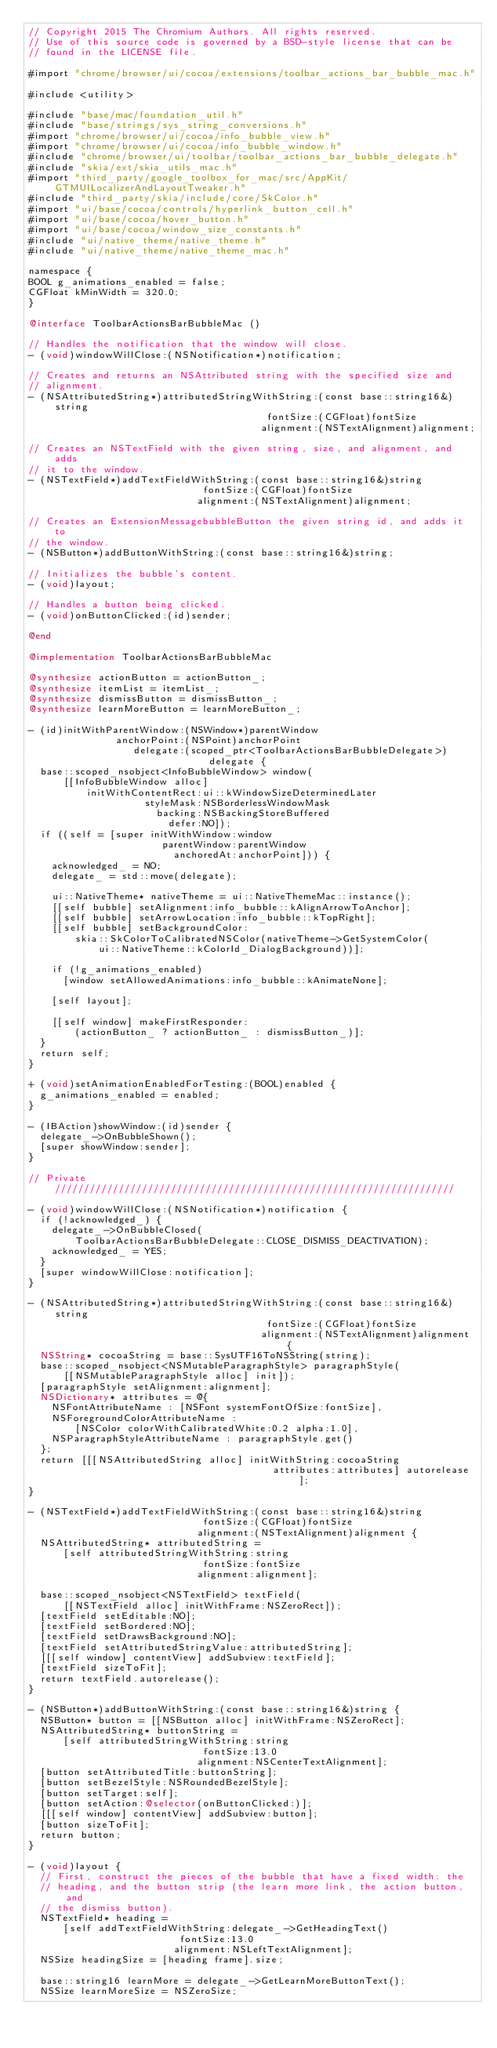<code> <loc_0><loc_0><loc_500><loc_500><_ObjectiveC_>// Copyright 2015 The Chromium Authors. All rights reserved.
// Use of this source code is governed by a BSD-style license that can be
// found in the LICENSE file.

#import "chrome/browser/ui/cocoa/extensions/toolbar_actions_bar_bubble_mac.h"

#include <utility>

#include "base/mac/foundation_util.h"
#include "base/strings/sys_string_conversions.h"
#import "chrome/browser/ui/cocoa/info_bubble_view.h"
#import "chrome/browser/ui/cocoa/info_bubble_window.h"
#include "chrome/browser/ui/toolbar/toolbar_actions_bar_bubble_delegate.h"
#include "skia/ext/skia_utils_mac.h"
#import "third_party/google_toolbox_for_mac/src/AppKit/GTMUILocalizerAndLayoutTweaker.h"
#include "third_party/skia/include/core/SkColor.h"
#import "ui/base/cocoa/controls/hyperlink_button_cell.h"
#import "ui/base/cocoa/hover_button.h"
#import "ui/base/cocoa/window_size_constants.h"
#include "ui/native_theme/native_theme.h"
#include "ui/native_theme/native_theme_mac.h"

namespace {
BOOL g_animations_enabled = false;
CGFloat kMinWidth = 320.0;
}

@interface ToolbarActionsBarBubbleMac ()

// Handles the notification that the window will close.
- (void)windowWillClose:(NSNotification*)notification;

// Creates and returns an NSAttributed string with the specified size and
// alignment.
- (NSAttributedString*)attributedStringWithString:(const base::string16&)string
                                         fontSize:(CGFloat)fontSize
                                        alignment:(NSTextAlignment)alignment;

// Creates an NSTextField with the given string, size, and alignment, and adds
// it to the window.
- (NSTextField*)addTextFieldWithString:(const base::string16&)string
                              fontSize:(CGFloat)fontSize
                             alignment:(NSTextAlignment)alignment;

// Creates an ExtensionMessagebubbleButton the given string id, and adds it to
// the window.
- (NSButton*)addButtonWithString:(const base::string16&)string;

// Initializes the bubble's content.
- (void)layout;

// Handles a button being clicked.
- (void)onButtonClicked:(id)sender;

@end

@implementation ToolbarActionsBarBubbleMac

@synthesize actionButton = actionButton_;
@synthesize itemList = itemList_;
@synthesize dismissButton = dismissButton_;
@synthesize learnMoreButton = learnMoreButton_;

- (id)initWithParentWindow:(NSWindow*)parentWindow
               anchorPoint:(NSPoint)anchorPoint
                  delegate:(scoped_ptr<ToolbarActionsBarBubbleDelegate>)
                               delegate {
  base::scoped_nsobject<InfoBubbleWindow> window(
      [[InfoBubbleWindow alloc]
          initWithContentRect:ui::kWindowSizeDeterminedLater
                    styleMask:NSBorderlessWindowMask
                      backing:NSBackingStoreBuffered
                        defer:NO]);
  if ((self = [super initWithWindow:window
                       parentWindow:parentWindow
                         anchoredAt:anchorPoint])) {
    acknowledged_ = NO;
    delegate_ = std::move(delegate);

    ui::NativeTheme* nativeTheme = ui::NativeThemeMac::instance();
    [[self bubble] setAlignment:info_bubble::kAlignArrowToAnchor];
    [[self bubble] setArrowLocation:info_bubble::kTopRight];
    [[self bubble] setBackgroundColor:
        skia::SkColorToCalibratedNSColor(nativeTheme->GetSystemColor(
            ui::NativeTheme::kColorId_DialogBackground))];

    if (!g_animations_enabled)
      [window setAllowedAnimations:info_bubble::kAnimateNone];

    [self layout];

    [[self window] makeFirstResponder:
        (actionButton_ ? actionButton_ : dismissButton_)];
  }
  return self;
}

+ (void)setAnimationEnabledForTesting:(BOOL)enabled {
  g_animations_enabled = enabled;
}

- (IBAction)showWindow:(id)sender {
  delegate_->OnBubbleShown();
  [super showWindow:sender];
}

// Private /////////////////////////////////////////////////////////////////////

- (void)windowWillClose:(NSNotification*)notification {
  if (!acknowledged_) {
    delegate_->OnBubbleClosed(
        ToolbarActionsBarBubbleDelegate::CLOSE_DISMISS_DEACTIVATION);
    acknowledged_ = YES;
  }
  [super windowWillClose:notification];
}

- (NSAttributedString*)attributedStringWithString:(const base::string16&)string
                                         fontSize:(CGFloat)fontSize
                                        alignment:(NSTextAlignment)alignment {
  NSString* cocoaString = base::SysUTF16ToNSString(string);
  base::scoped_nsobject<NSMutableParagraphStyle> paragraphStyle(
      [[NSMutableParagraphStyle alloc] init]);
  [paragraphStyle setAlignment:alignment];
  NSDictionary* attributes = @{
    NSFontAttributeName : [NSFont systemFontOfSize:fontSize],
    NSForegroundColorAttributeName :
        [NSColor colorWithCalibratedWhite:0.2 alpha:1.0],
    NSParagraphStyleAttributeName : paragraphStyle.get()
  };
  return [[[NSAttributedString alloc] initWithString:cocoaString
                                          attributes:attributes] autorelease];
}

- (NSTextField*)addTextFieldWithString:(const base::string16&)string
                              fontSize:(CGFloat)fontSize
                             alignment:(NSTextAlignment)alignment {
  NSAttributedString* attributedString =
      [self attributedStringWithString:string
                              fontSize:fontSize
                             alignment:alignment];

  base::scoped_nsobject<NSTextField> textField(
      [[NSTextField alloc] initWithFrame:NSZeroRect]);
  [textField setEditable:NO];
  [textField setBordered:NO];
  [textField setDrawsBackground:NO];
  [textField setAttributedStringValue:attributedString];
  [[[self window] contentView] addSubview:textField];
  [textField sizeToFit];
  return textField.autorelease();
}

- (NSButton*)addButtonWithString:(const base::string16&)string {
  NSButton* button = [[NSButton alloc] initWithFrame:NSZeroRect];
  NSAttributedString* buttonString =
      [self attributedStringWithString:string
                              fontSize:13.0
                             alignment:NSCenterTextAlignment];
  [button setAttributedTitle:buttonString];
  [button setBezelStyle:NSRoundedBezelStyle];
  [button setTarget:self];
  [button setAction:@selector(onButtonClicked:)];
  [[[self window] contentView] addSubview:button];
  [button sizeToFit];
  return button;
}

- (void)layout {
  // First, construct the pieces of the bubble that have a fixed width: the
  // heading, and the button strip (the learn more link, the action button, and
  // the dismiss button).
  NSTextField* heading =
      [self addTextFieldWithString:delegate_->GetHeadingText()
                          fontSize:13.0
                         alignment:NSLeftTextAlignment];
  NSSize headingSize = [heading frame].size;

  base::string16 learnMore = delegate_->GetLearnMoreButtonText();
  NSSize learnMoreSize = NSZeroSize;</code> 